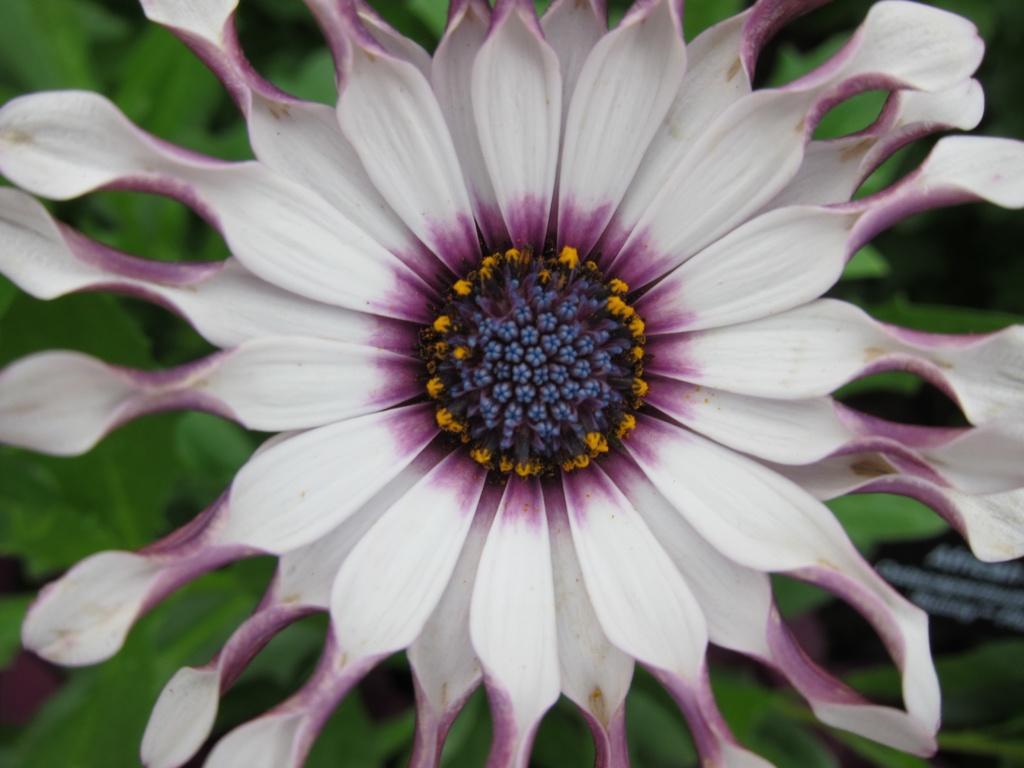In one or two sentences, can you explain what this image depicts? In this picture there is a flower in the center of the image and there are leaves in the background area of the image. 